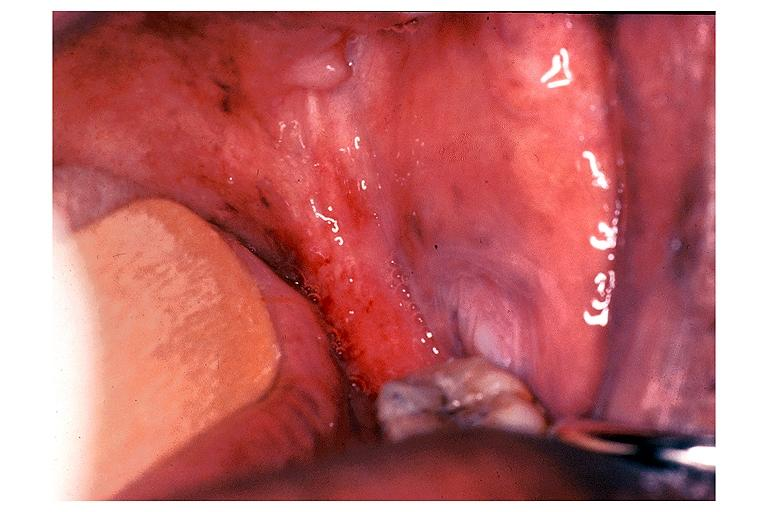does this image show erythroplakia?
Answer the question using a single word or phrase. Yes 